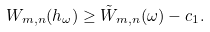Convert formula to latex. <formula><loc_0><loc_0><loc_500><loc_500>W _ { m , n } ( h _ { \omega } ) \geq \tilde { W } _ { m , n } ( \omega ) - c _ { 1 } .</formula> 